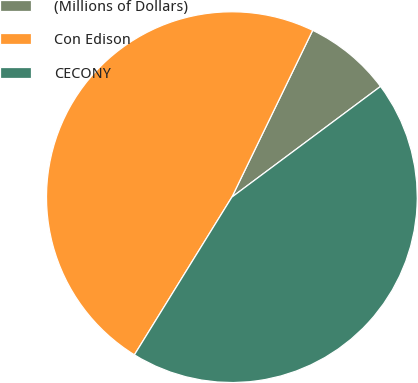Convert chart to OTSL. <chart><loc_0><loc_0><loc_500><loc_500><pie_chart><fcel>(Millions of Dollars)<fcel>Con Edison<fcel>CECONY<nl><fcel>7.63%<fcel>48.37%<fcel>44.0%<nl></chart> 